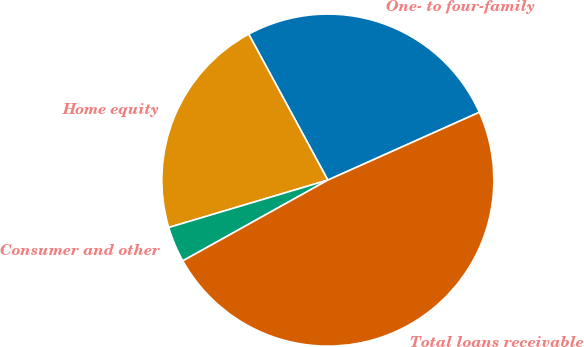Convert chart to OTSL. <chart><loc_0><loc_0><loc_500><loc_500><pie_chart><fcel>One- to four-family<fcel>Home equity<fcel>Consumer and other<fcel>Total loans receivable<nl><fcel>26.21%<fcel>21.7%<fcel>3.48%<fcel>48.61%<nl></chart> 